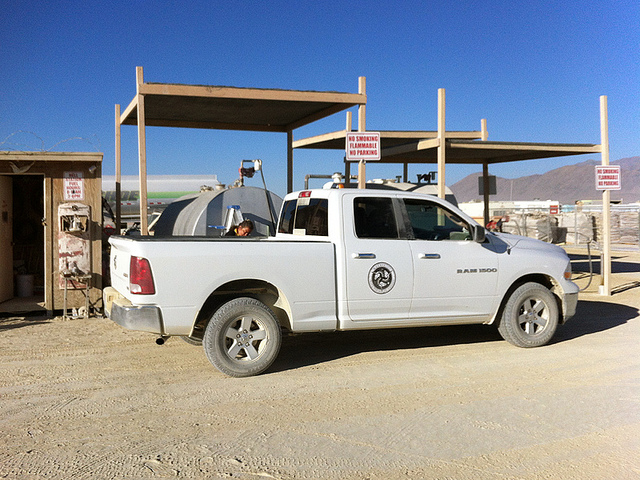<image>Where is a silver ladder? I don't know where the silver ladder is. It is not visible in the image. Where is a silver ladder? I am not sure where a silver ladder is. It can be seen behind truck or near the shed. 